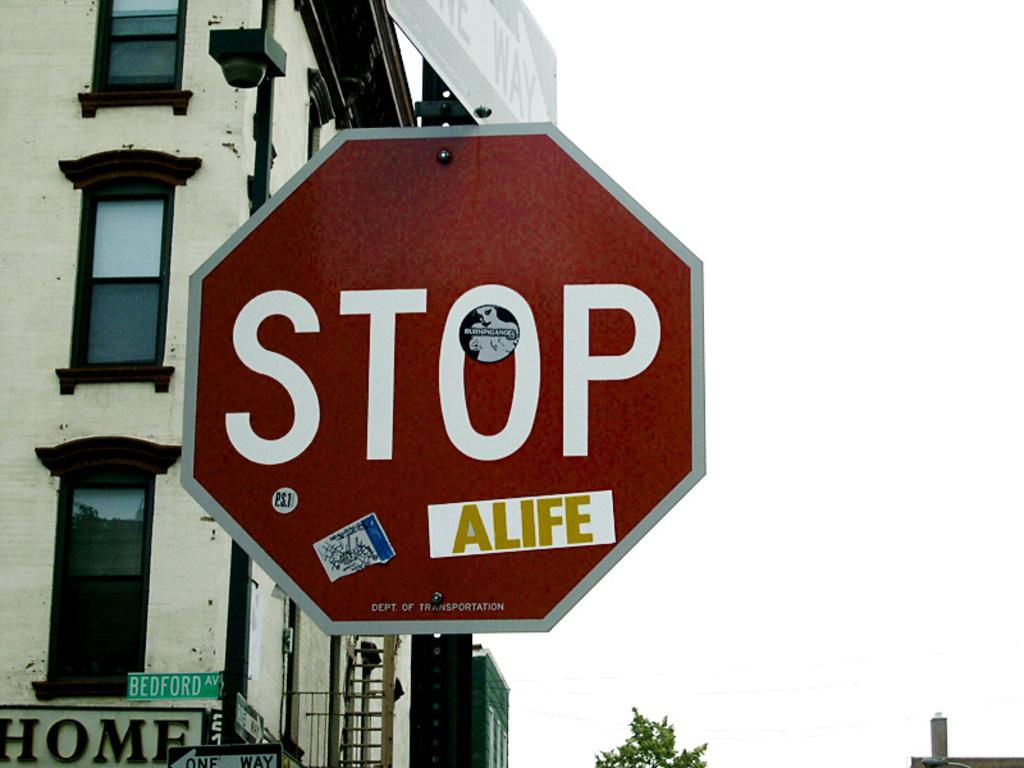<image>
Relay a brief, clear account of the picture shown. A large stop sign on Bedford Ave has numerous stickers on it. 